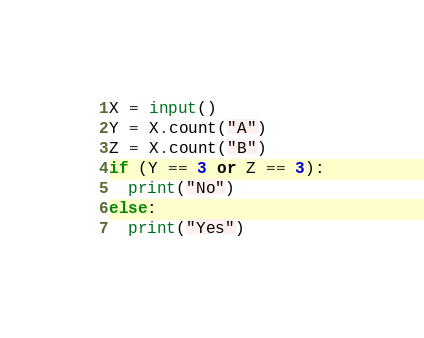Convert code to text. <code><loc_0><loc_0><loc_500><loc_500><_Python_>X = input()
Y = X.count("A")
Z = X.count("B")
if (Y == 3 or Z == 3):
  print("No")
else:
  print("Yes")</code> 